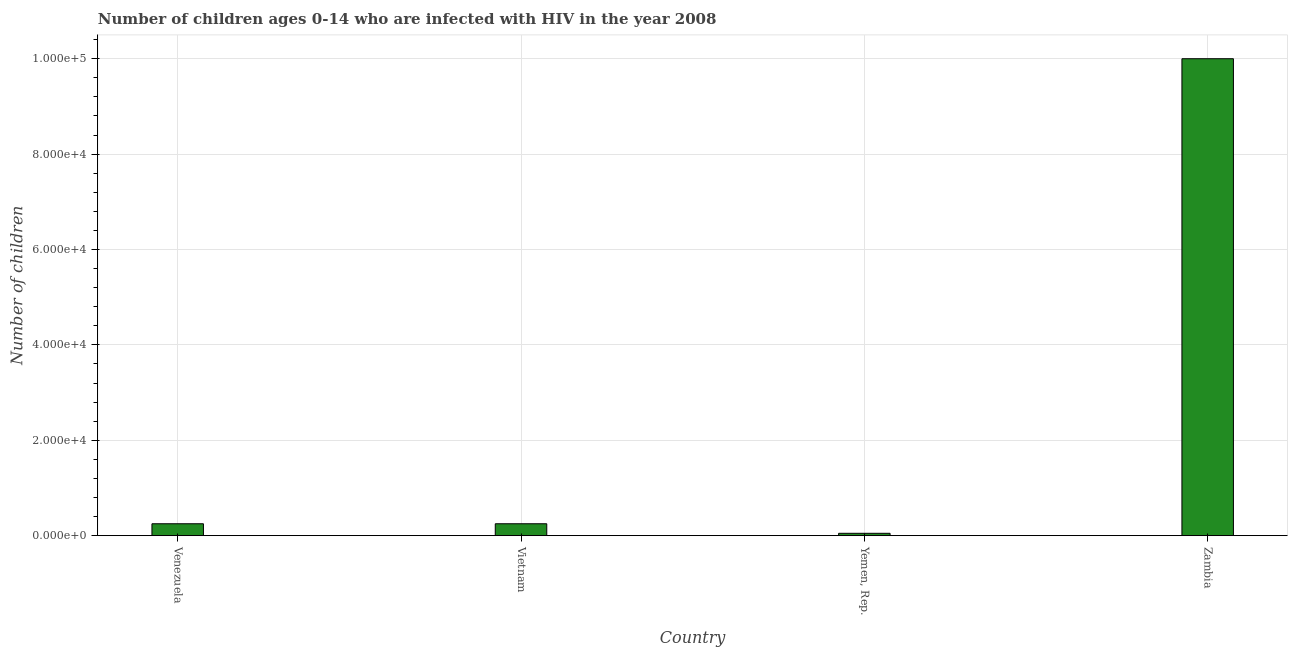Does the graph contain any zero values?
Make the answer very short. No. What is the title of the graph?
Make the answer very short. Number of children ages 0-14 who are infected with HIV in the year 2008. What is the label or title of the Y-axis?
Provide a succinct answer. Number of children. What is the number of children living with hiv in Yemen, Rep.?
Make the answer very short. 500. Across all countries, what is the maximum number of children living with hiv?
Ensure brevity in your answer.  1.00e+05. In which country was the number of children living with hiv maximum?
Keep it short and to the point. Zambia. In which country was the number of children living with hiv minimum?
Offer a terse response. Yemen, Rep. What is the sum of the number of children living with hiv?
Your response must be concise. 1.06e+05. What is the difference between the number of children living with hiv in Venezuela and Vietnam?
Your answer should be very brief. 0. What is the average number of children living with hiv per country?
Your response must be concise. 2.64e+04. What is the median number of children living with hiv?
Provide a short and direct response. 2500. Is the difference between the number of children living with hiv in Vietnam and Zambia greater than the difference between any two countries?
Offer a very short reply. No. What is the difference between the highest and the second highest number of children living with hiv?
Your response must be concise. 9.75e+04. What is the difference between the highest and the lowest number of children living with hiv?
Your response must be concise. 9.95e+04. In how many countries, is the number of children living with hiv greater than the average number of children living with hiv taken over all countries?
Offer a very short reply. 1. What is the Number of children of Venezuela?
Your response must be concise. 2500. What is the Number of children of Vietnam?
Keep it short and to the point. 2500. What is the Number of children of Yemen, Rep.?
Offer a terse response. 500. What is the difference between the Number of children in Venezuela and Vietnam?
Provide a succinct answer. 0. What is the difference between the Number of children in Venezuela and Yemen, Rep.?
Provide a short and direct response. 2000. What is the difference between the Number of children in Venezuela and Zambia?
Your answer should be compact. -9.75e+04. What is the difference between the Number of children in Vietnam and Zambia?
Offer a very short reply. -9.75e+04. What is the difference between the Number of children in Yemen, Rep. and Zambia?
Your answer should be compact. -9.95e+04. What is the ratio of the Number of children in Venezuela to that in Vietnam?
Offer a very short reply. 1. What is the ratio of the Number of children in Venezuela to that in Yemen, Rep.?
Offer a terse response. 5. What is the ratio of the Number of children in Venezuela to that in Zambia?
Offer a terse response. 0.03. What is the ratio of the Number of children in Vietnam to that in Zambia?
Ensure brevity in your answer.  0.03. What is the ratio of the Number of children in Yemen, Rep. to that in Zambia?
Offer a terse response. 0.01. 